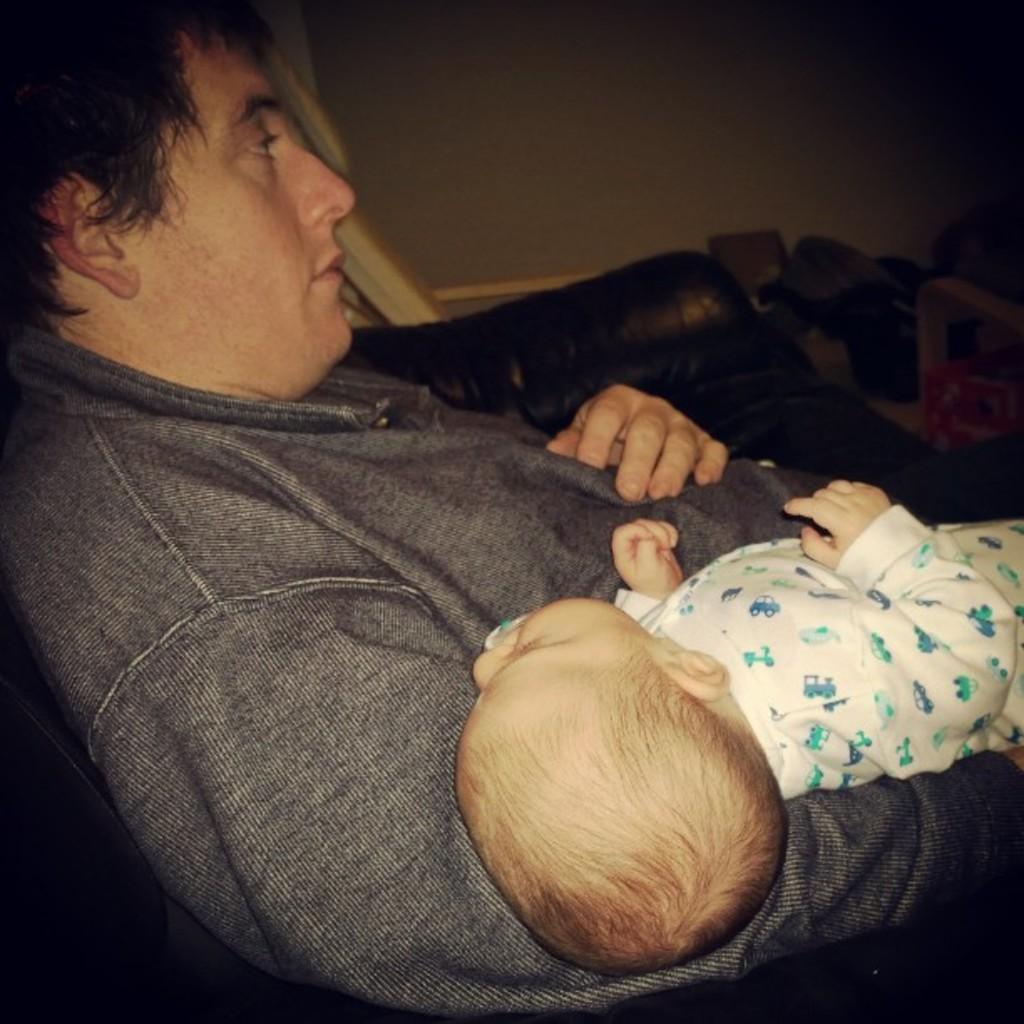Describe this image in one or two sentences. In the image there is a man laying on a sofa and he is holding a baby in his arms and beside the sofa there are some other things. 